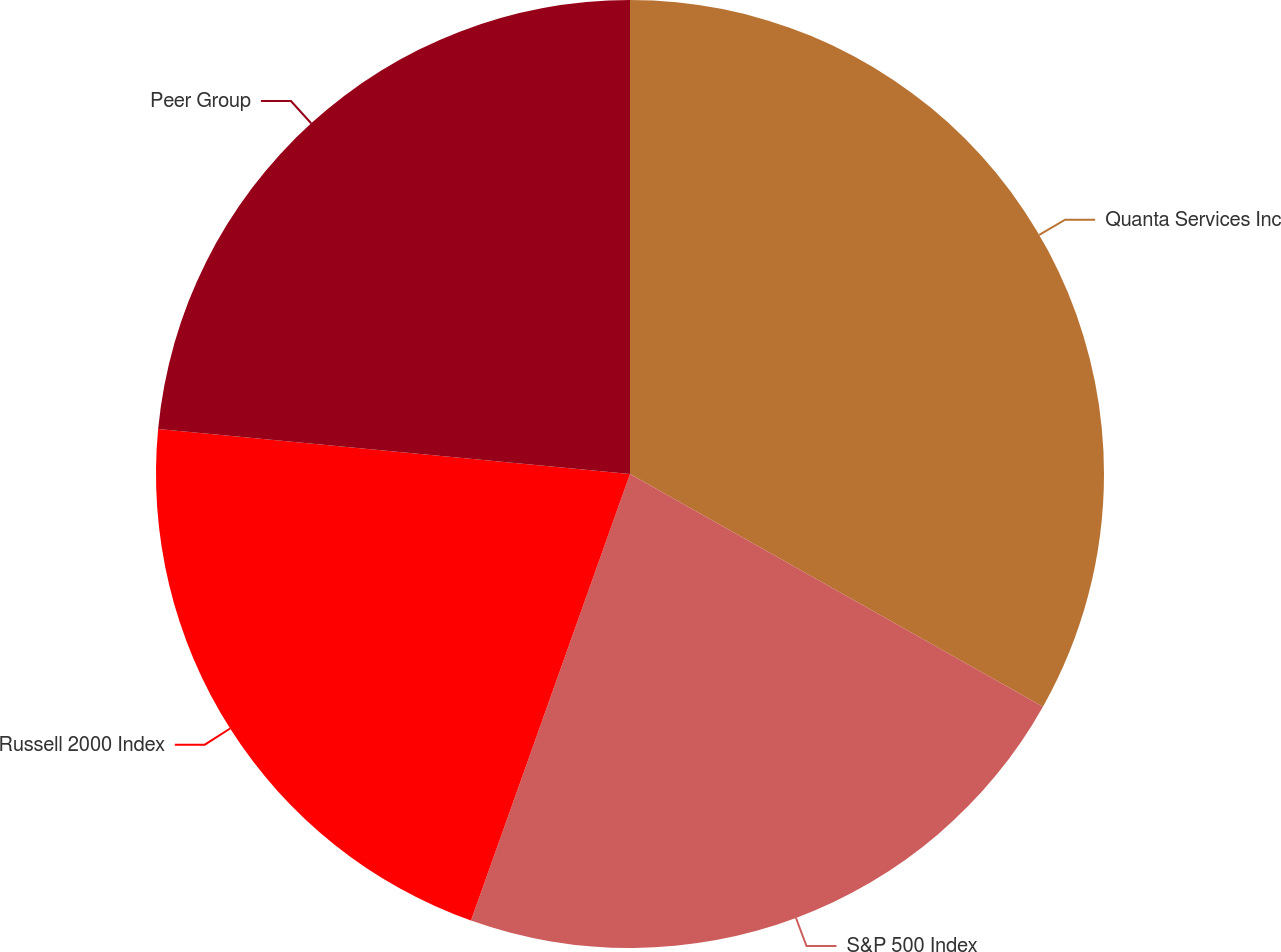Convert chart to OTSL. <chart><loc_0><loc_0><loc_500><loc_500><pie_chart><fcel>Quanta Services Inc<fcel>S&P 500 Index<fcel>Russell 2000 Index<fcel>Peer Group<nl><fcel>33.17%<fcel>22.28%<fcel>21.07%<fcel>23.49%<nl></chart> 